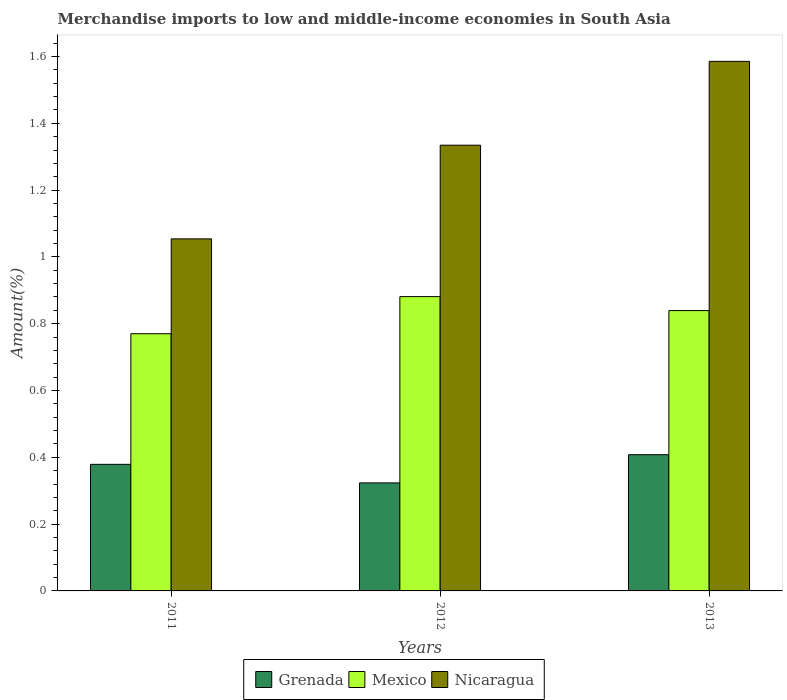Are the number of bars on each tick of the X-axis equal?
Make the answer very short. Yes. How many bars are there on the 1st tick from the left?
Provide a succinct answer. 3. How many bars are there on the 2nd tick from the right?
Make the answer very short. 3. What is the label of the 1st group of bars from the left?
Provide a short and direct response. 2011. What is the percentage of amount earned from merchandise imports in Mexico in 2013?
Offer a very short reply. 0.84. Across all years, what is the maximum percentage of amount earned from merchandise imports in Nicaragua?
Your answer should be very brief. 1.59. Across all years, what is the minimum percentage of amount earned from merchandise imports in Mexico?
Keep it short and to the point. 0.77. What is the total percentage of amount earned from merchandise imports in Nicaragua in the graph?
Make the answer very short. 3.97. What is the difference between the percentage of amount earned from merchandise imports in Mexico in 2011 and that in 2013?
Ensure brevity in your answer.  -0.07. What is the difference between the percentage of amount earned from merchandise imports in Grenada in 2012 and the percentage of amount earned from merchandise imports in Nicaragua in 2013?
Your answer should be compact. -1.26. What is the average percentage of amount earned from merchandise imports in Grenada per year?
Offer a terse response. 0.37. In the year 2012, what is the difference between the percentage of amount earned from merchandise imports in Grenada and percentage of amount earned from merchandise imports in Mexico?
Give a very brief answer. -0.56. In how many years, is the percentage of amount earned from merchandise imports in Mexico greater than 0.24000000000000002 %?
Offer a terse response. 3. What is the ratio of the percentage of amount earned from merchandise imports in Nicaragua in 2012 to that in 2013?
Your answer should be very brief. 0.84. Is the percentage of amount earned from merchandise imports in Nicaragua in 2011 less than that in 2012?
Make the answer very short. Yes. What is the difference between the highest and the second highest percentage of amount earned from merchandise imports in Nicaragua?
Offer a very short reply. 0.25. What is the difference between the highest and the lowest percentage of amount earned from merchandise imports in Nicaragua?
Provide a succinct answer. 0.53. In how many years, is the percentage of amount earned from merchandise imports in Mexico greater than the average percentage of amount earned from merchandise imports in Mexico taken over all years?
Your answer should be compact. 2. Is the sum of the percentage of amount earned from merchandise imports in Grenada in 2012 and 2013 greater than the maximum percentage of amount earned from merchandise imports in Mexico across all years?
Your answer should be very brief. No. What does the 1st bar from the left in 2013 represents?
Offer a very short reply. Grenada. What does the 1st bar from the right in 2011 represents?
Make the answer very short. Nicaragua. How many bars are there?
Offer a terse response. 9. Are all the bars in the graph horizontal?
Offer a very short reply. No. Are the values on the major ticks of Y-axis written in scientific E-notation?
Make the answer very short. No. Where does the legend appear in the graph?
Your answer should be compact. Bottom center. What is the title of the graph?
Provide a short and direct response. Merchandise imports to low and middle-income economies in South Asia. Does "Lebanon" appear as one of the legend labels in the graph?
Give a very brief answer. No. What is the label or title of the Y-axis?
Offer a very short reply. Amount(%). What is the Amount(%) of Grenada in 2011?
Your answer should be very brief. 0.38. What is the Amount(%) in Mexico in 2011?
Provide a succinct answer. 0.77. What is the Amount(%) of Nicaragua in 2011?
Your response must be concise. 1.05. What is the Amount(%) of Grenada in 2012?
Offer a terse response. 0.32. What is the Amount(%) of Mexico in 2012?
Keep it short and to the point. 0.88. What is the Amount(%) of Nicaragua in 2012?
Make the answer very short. 1.33. What is the Amount(%) in Grenada in 2013?
Your answer should be very brief. 0.41. What is the Amount(%) in Mexico in 2013?
Make the answer very short. 0.84. What is the Amount(%) in Nicaragua in 2013?
Offer a very short reply. 1.59. Across all years, what is the maximum Amount(%) in Grenada?
Give a very brief answer. 0.41. Across all years, what is the maximum Amount(%) in Mexico?
Give a very brief answer. 0.88. Across all years, what is the maximum Amount(%) in Nicaragua?
Make the answer very short. 1.59. Across all years, what is the minimum Amount(%) in Grenada?
Offer a very short reply. 0.32. Across all years, what is the minimum Amount(%) in Mexico?
Offer a very short reply. 0.77. Across all years, what is the minimum Amount(%) of Nicaragua?
Provide a succinct answer. 1.05. What is the total Amount(%) in Grenada in the graph?
Make the answer very short. 1.11. What is the total Amount(%) in Mexico in the graph?
Provide a succinct answer. 2.49. What is the total Amount(%) in Nicaragua in the graph?
Ensure brevity in your answer.  3.97. What is the difference between the Amount(%) of Grenada in 2011 and that in 2012?
Give a very brief answer. 0.06. What is the difference between the Amount(%) in Mexico in 2011 and that in 2012?
Provide a short and direct response. -0.11. What is the difference between the Amount(%) of Nicaragua in 2011 and that in 2012?
Provide a succinct answer. -0.28. What is the difference between the Amount(%) of Grenada in 2011 and that in 2013?
Offer a very short reply. -0.03. What is the difference between the Amount(%) of Mexico in 2011 and that in 2013?
Give a very brief answer. -0.07. What is the difference between the Amount(%) of Nicaragua in 2011 and that in 2013?
Ensure brevity in your answer.  -0.53. What is the difference between the Amount(%) of Grenada in 2012 and that in 2013?
Your answer should be compact. -0.08. What is the difference between the Amount(%) in Mexico in 2012 and that in 2013?
Provide a short and direct response. 0.04. What is the difference between the Amount(%) of Nicaragua in 2012 and that in 2013?
Give a very brief answer. -0.25. What is the difference between the Amount(%) in Grenada in 2011 and the Amount(%) in Mexico in 2012?
Make the answer very short. -0.5. What is the difference between the Amount(%) of Grenada in 2011 and the Amount(%) of Nicaragua in 2012?
Give a very brief answer. -0.96. What is the difference between the Amount(%) in Mexico in 2011 and the Amount(%) in Nicaragua in 2012?
Your answer should be compact. -0.56. What is the difference between the Amount(%) of Grenada in 2011 and the Amount(%) of Mexico in 2013?
Your response must be concise. -0.46. What is the difference between the Amount(%) of Grenada in 2011 and the Amount(%) of Nicaragua in 2013?
Make the answer very short. -1.21. What is the difference between the Amount(%) of Mexico in 2011 and the Amount(%) of Nicaragua in 2013?
Offer a terse response. -0.82. What is the difference between the Amount(%) of Grenada in 2012 and the Amount(%) of Mexico in 2013?
Offer a terse response. -0.52. What is the difference between the Amount(%) in Grenada in 2012 and the Amount(%) in Nicaragua in 2013?
Offer a very short reply. -1.26. What is the difference between the Amount(%) of Mexico in 2012 and the Amount(%) of Nicaragua in 2013?
Provide a short and direct response. -0.7. What is the average Amount(%) in Grenada per year?
Offer a very short reply. 0.37. What is the average Amount(%) of Mexico per year?
Make the answer very short. 0.83. What is the average Amount(%) of Nicaragua per year?
Make the answer very short. 1.32. In the year 2011, what is the difference between the Amount(%) of Grenada and Amount(%) of Mexico?
Give a very brief answer. -0.39. In the year 2011, what is the difference between the Amount(%) of Grenada and Amount(%) of Nicaragua?
Provide a succinct answer. -0.68. In the year 2011, what is the difference between the Amount(%) in Mexico and Amount(%) in Nicaragua?
Offer a terse response. -0.28. In the year 2012, what is the difference between the Amount(%) in Grenada and Amount(%) in Mexico?
Make the answer very short. -0.56. In the year 2012, what is the difference between the Amount(%) of Grenada and Amount(%) of Nicaragua?
Make the answer very short. -1.01. In the year 2012, what is the difference between the Amount(%) in Mexico and Amount(%) in Nicaragua?
Keep it short and to the point. -0.45. In the year 2013, what is the difference between the Amount(%) of Grenada and Amount(%) of Mexico?
Give a very brief answer. -0.43. In the year 2013, what is the difference between the Amount(%) of Grenada and Amount(%) of Nicaragua?
Provide a short and direct response. -1.18. In the year 2013, what is the difference between the Amount(%) of Mexico and Amount(%) of Nicaragua?
Your answer should be compact. -0.75. What is the ratio of the Amount(%) of Grenada in 2011 to that in 2012?
Offer a very short reply. 1.17. What is the ratio of the Amount(%) in Mexico in 2011 to that in 2012?
Your response must be concise. 0.87. What is the ratio of the Amount(%) in Nicaragua in 2011 to that in 2012?
Your answer should be compact. 0.79. What is the ratio of the Amount(%) of Grenada in 2011 to that in 2013?
Offer a very short reply. 0.93. What is the ratio of the Amount(%) in Mexico in 2011 to that in 2013?
Provide a succinct answer. 0.92. What is the ratio of the Amount(%) in Nicaragua in 2011 to that in 2013?
Keep it short and to the point. 0.66. What is the ratio of the Amount(%) of Grenada in 2012 to that in 2013?
Give a very brief answer. 0.79. What is the ratio of the Amount(%) of Mexico in 2012 to that in 2013?
Make the answer very short. 1.05. What is the ratio of the Amount(%) in Nicaragua in 2012 to that in 2013?
Provide a short and direct response. 0.84. What is the difference between the highest and the second highest Amount(%) in Grenada?
Your answer should be very brief. 0.03. What is the difference between the highest and the second highest Amount(%) of Mexico?
Make the answer very short. 0.04. What is the difference between the highest and the second highest Amount(%) in Nicaragua?
Offer a terse response. 0.25. What is the difference between the highest and the lowest Amount(%) in Grenada?
Provide a succinct answer. 0.08. What is the difference between the highest and the lowest Amount(%) of Mexico?
Ensure brevity in your answer.  0.11. What is the difference between the highest and the lowest Amount(%) of Nicaragua?
Your response must be concise. 0.53. 